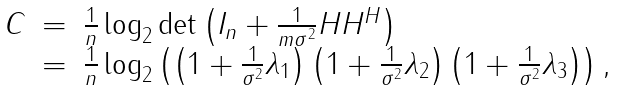<formula> <loc_0><loc_0><loc_500><loc_500>\begin{array} { l l l } C & = & \frac { 1 } { n } \log _ { 2 } \det \left ( { I } _ { n } + \frac { 1 } { m \sigma ^ { 2 } } { H } { H } ^ { H } \right ) \\ & = & \frac { 1 } { n } \log _ { 2 } \left ( \left ( 1 + \frac { 1 } { \sigma ^ { 2 } } \lambda _ { 1 } \right ) \left ( 1 + \frac { 1 } { \sigma ^ { 2 } } \lambda _ { 2 } \right ) \left ( 1 + \frac { 1 } { \sigma ^ { 2 } } \lambda _ { 3 } \right ) \right ) , \end{array}</formula> 